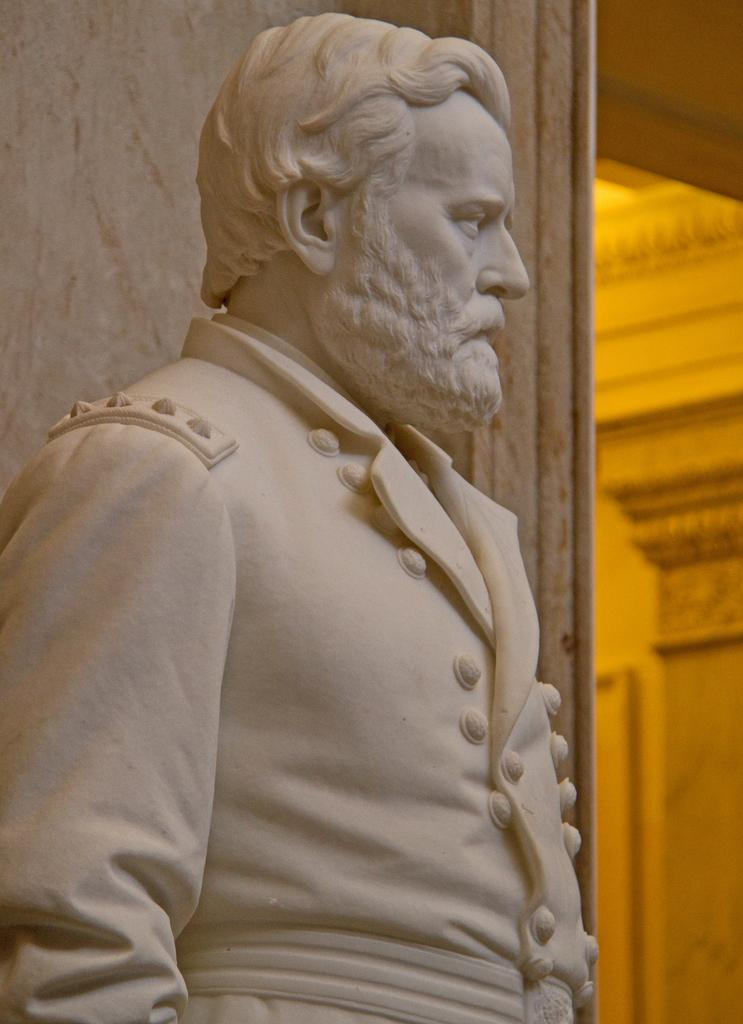What is the main subject of the image? There is a sculpture of a man in the image. What is located behind the sculpture? There is a wall behind the sculpture. How many bees can be seen buzzing around the sculpture in the image? There are no bees visible in the image; it only features a sculpture of a man and a wall. What type of material is the sculpture made of, such as steel or bronze? The provided facts do not mention the material of the sculpture, so it cannot be determined from the image. 